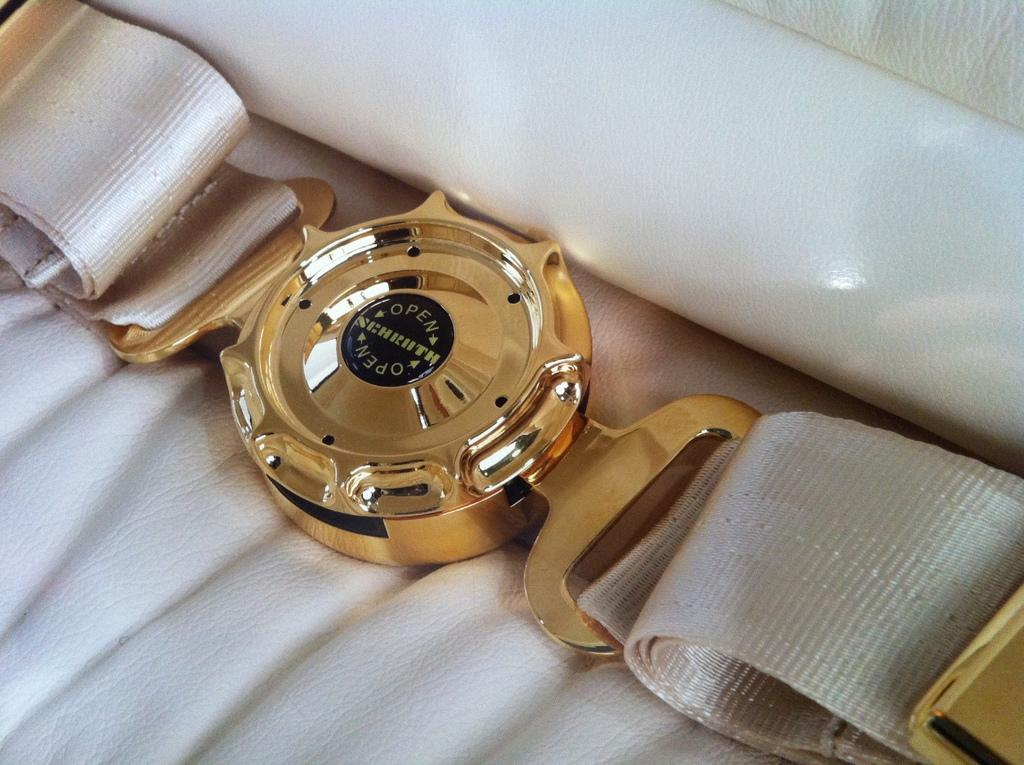<image>
Present a compact description of the photo's key features. The back of a white and gold belt that says open in the middle. 